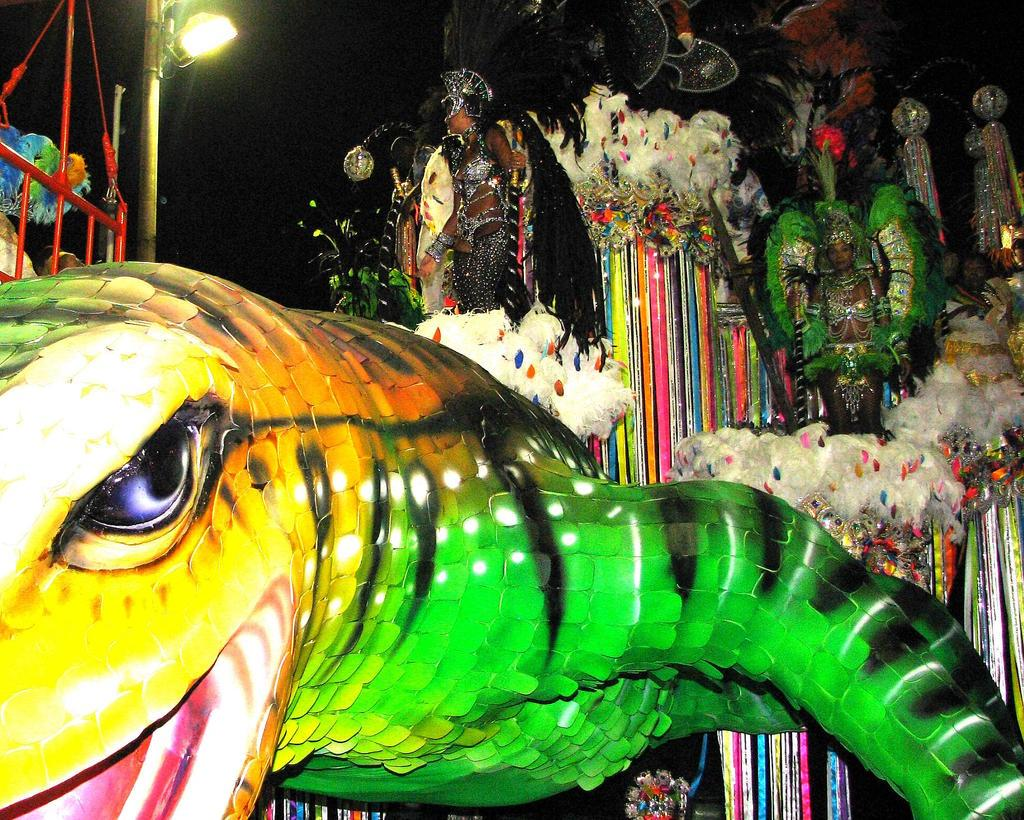What is located at the bottom of the image? There is a doll at the bottom of the image. What can be seen in the middle of the image? There are people standing in the middle of the image. What object is present in the image that has a pole? There is a pole in the image, and a light is on the pole. What type of curtain is hanging from the pole in the image? There is no curtain present in the image; it features a doll, people, and a light on a pole. Can you describe the house in the image? There is no house present in the image; it features a doll, people, and a light on a pole. 